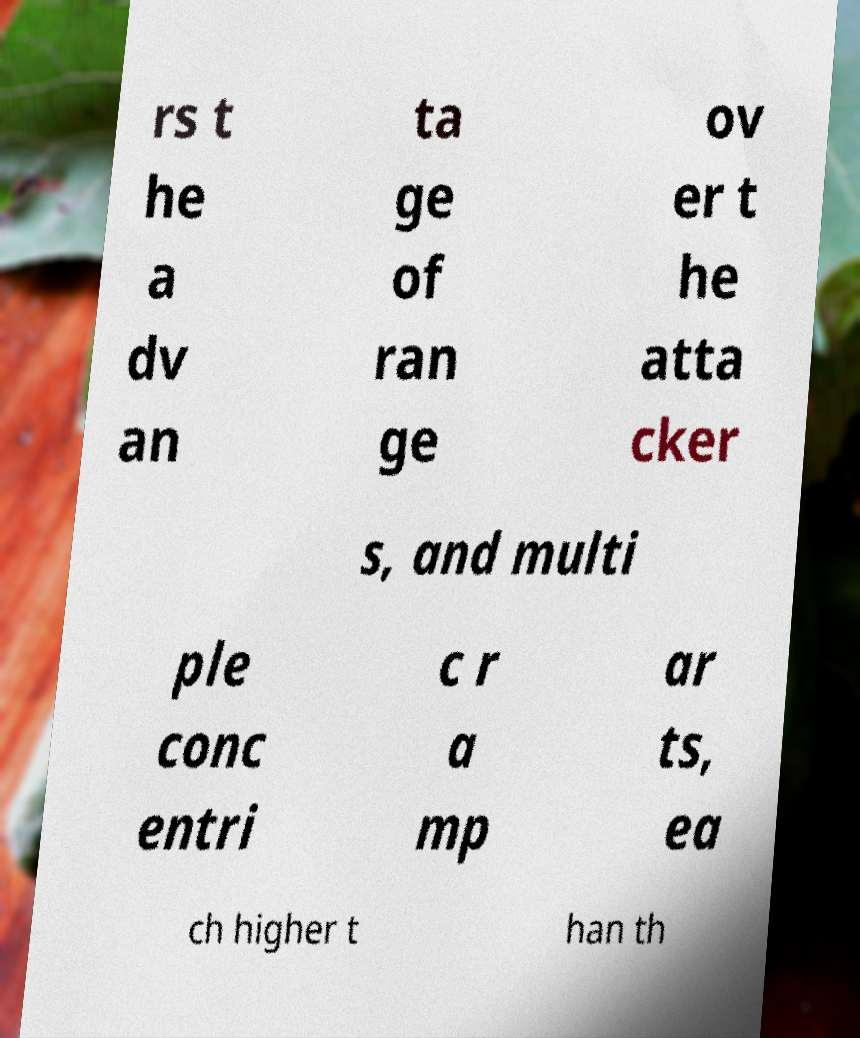Could you extract and type out the text from this image? rs t he a dv an ta ge of ran ge ov er t he atta cker s, and multi ple conc entri c r a mp ar ts, ea ch higher t han th 